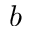Convert formula to latex. <formula><loc_0><loc_0><loc_500><loc_500>b</formula> 